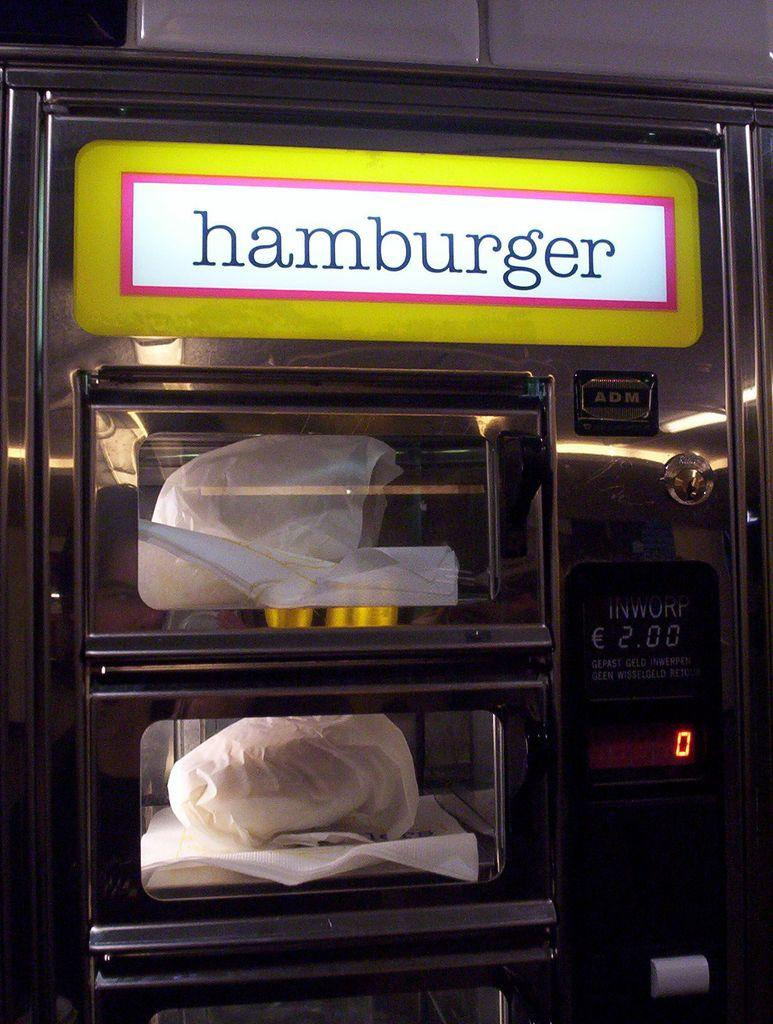<image>
Summarize the visual content of the image. Hamburger machine from ADM that contains a oven 